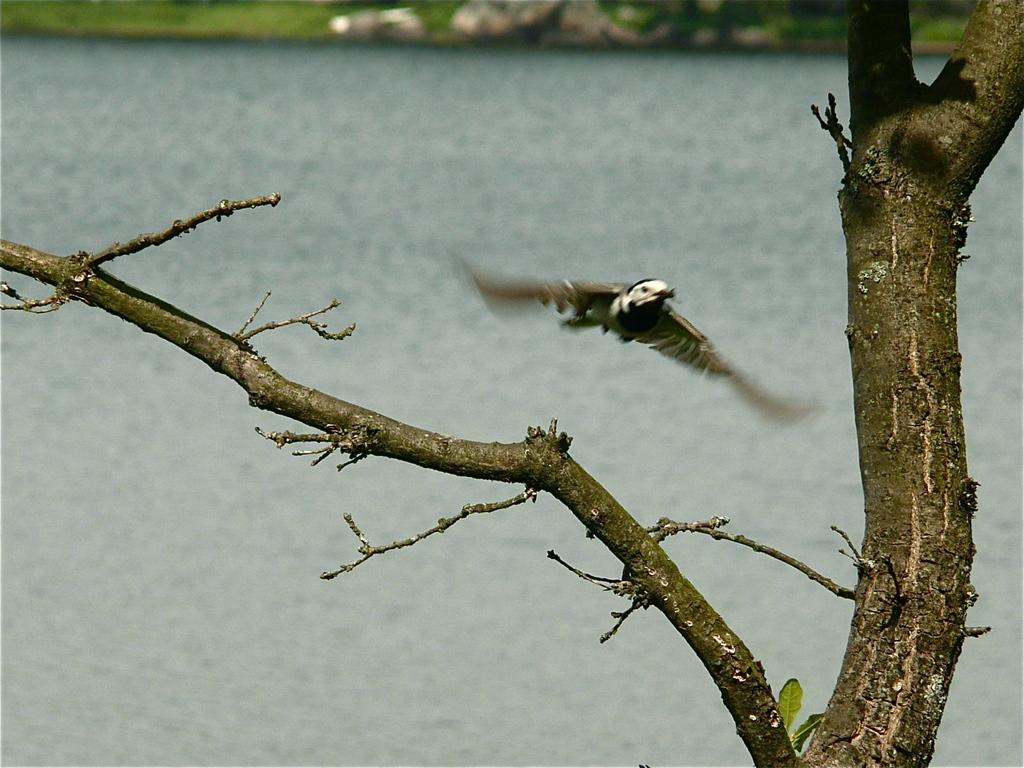What type of animal can be seen in the image? There is a bird in the air in the image. What is visible in the background of the image? There is a tree visible in the image. What type of prose is being recited by the bird in the image? There is no indication in the image that the bird is reciting any prose, as birds do not have the ability to speak or recite literature. 